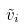Convert formula to latex. <formula><loc_0><loc_0><loc_500><loc_500>\tilde { v } _ { i }</formula> 